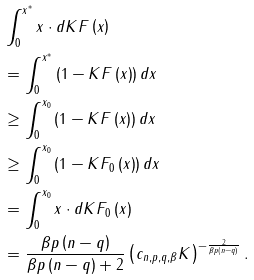<formula> <loc_0><loc_0><loc_500><loc_500>& \int _ { 0 } ^ { x ^ { * } } x \cdot d K F \left ( x \right ) \\ & = \int _ { 0 } ^ { x ^ { * } } \left ( 1 - K F \left ( x \right ) \right ) d x \\ & \geq \int _ { 0 } ^ { x _ { 0 } } \left ( 1 - K F \left ( x \right ) \right ) d x \\ & \geq \int _ { 0 } ^ { x _ { 0 } } \left ( 1 - K F _ { 0 } \left ( x \right ) \right ) d x \\ & = \int _ { 0 } ^ { x _ { 0 } } x \cdot d K F _ { 0 } \left ( x \right ) \\ & = \frac { \beta p \left ( n - q \right ) } { \beta p \left ( n - q \right ) + 2 } \left ( c _ { n , p , q , \beta } K \right ) ^ { - \frac { 2 } { \beta p \left ( n - q \right ) } } .</formula> 